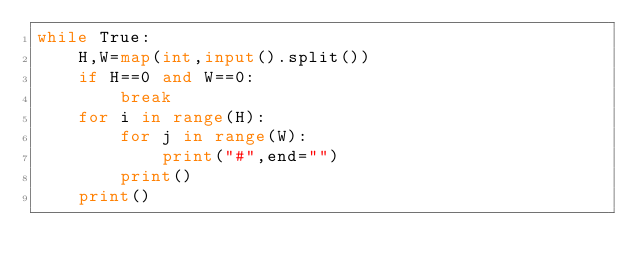Convert code to text. <code><loc_0><loc_0><loc_500><loc_500><_Python_>while True:
    H,W=map(int,input().split())
    if H==0 and W==0:
        break
    for i in range(H):
        for j in range(W):
            print("#",end="")
        print()
    print()
</code> 